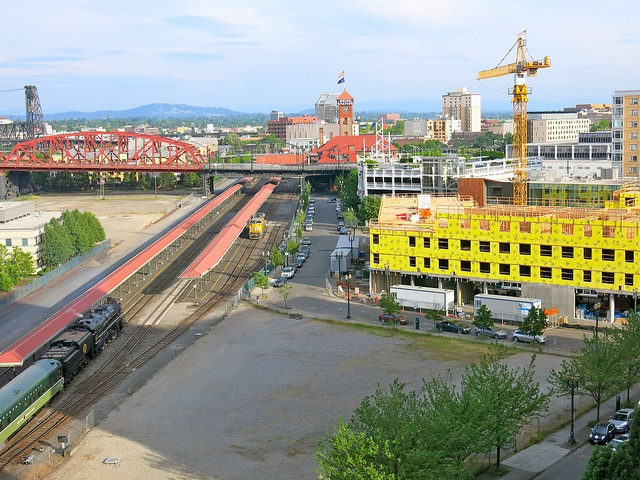Describe the objects in this image and their specific colors. I can see train in lavender, black, gray, and darkgray tones, truck in lavender, lightgray, darkgray, gray, and black tones, car in lavender, gray, black, blue, and darkgray tones, truck in lavender, darkgray, lightgray, black, and gray tones, and truck in lavender, gray, and darkgray tones in this image. 